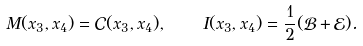Convert formula to latex. <formula><loc_0><loc_0><loc_500><loc_500>M ( x _ { 3 } , x _ { 4 } ) = \mathcal { C } ( x _ { 3 } , x _ { 4 } ) , \quad I ( x _ { 3 } , x _ { 4 } ) = \frac { 1 } { 2 } ( \mathcal { B } + \mathcal { E } ) .</formula> 